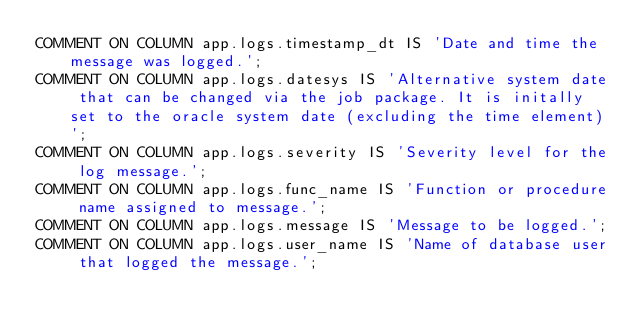<code> <loc_0><loc_0><loc_500><loc_500><_SQL_>COMMENT ON COLUMN app.logs.timestamp_dt IS 'Date and time the message was logged.';
COMMENT ON COLUMN app.logs.datesys IS 'Alternative system date that can be changed via the job package. It is initally set to the oracle system date (excluding the time element)';
COMMENT ON COLUMN app.logs.severity IS 'Severity level for the log message.';
COMMENT ON COLUMN app.logs.func_name IS 'Function or procedure name assigned to message.';
COMMENT ON COLUMN app.logs.message IS 'Message to be logged.';
COMMENT ON COLUMN app.logs.user_name IS 'Name of database user that logged the message.';

</code> 